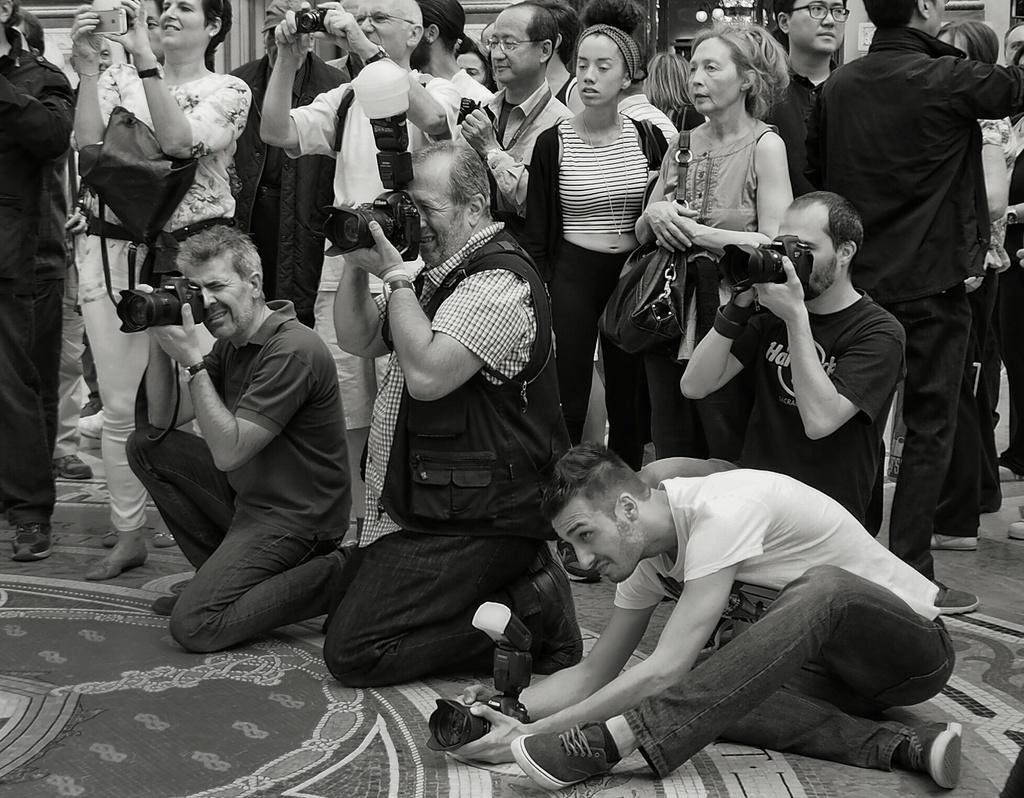In one or two sentences, can you explain what this image depicts? In this picture we can see some people standing here, these four persons are holding cameras, this woman is carrying a bag. 